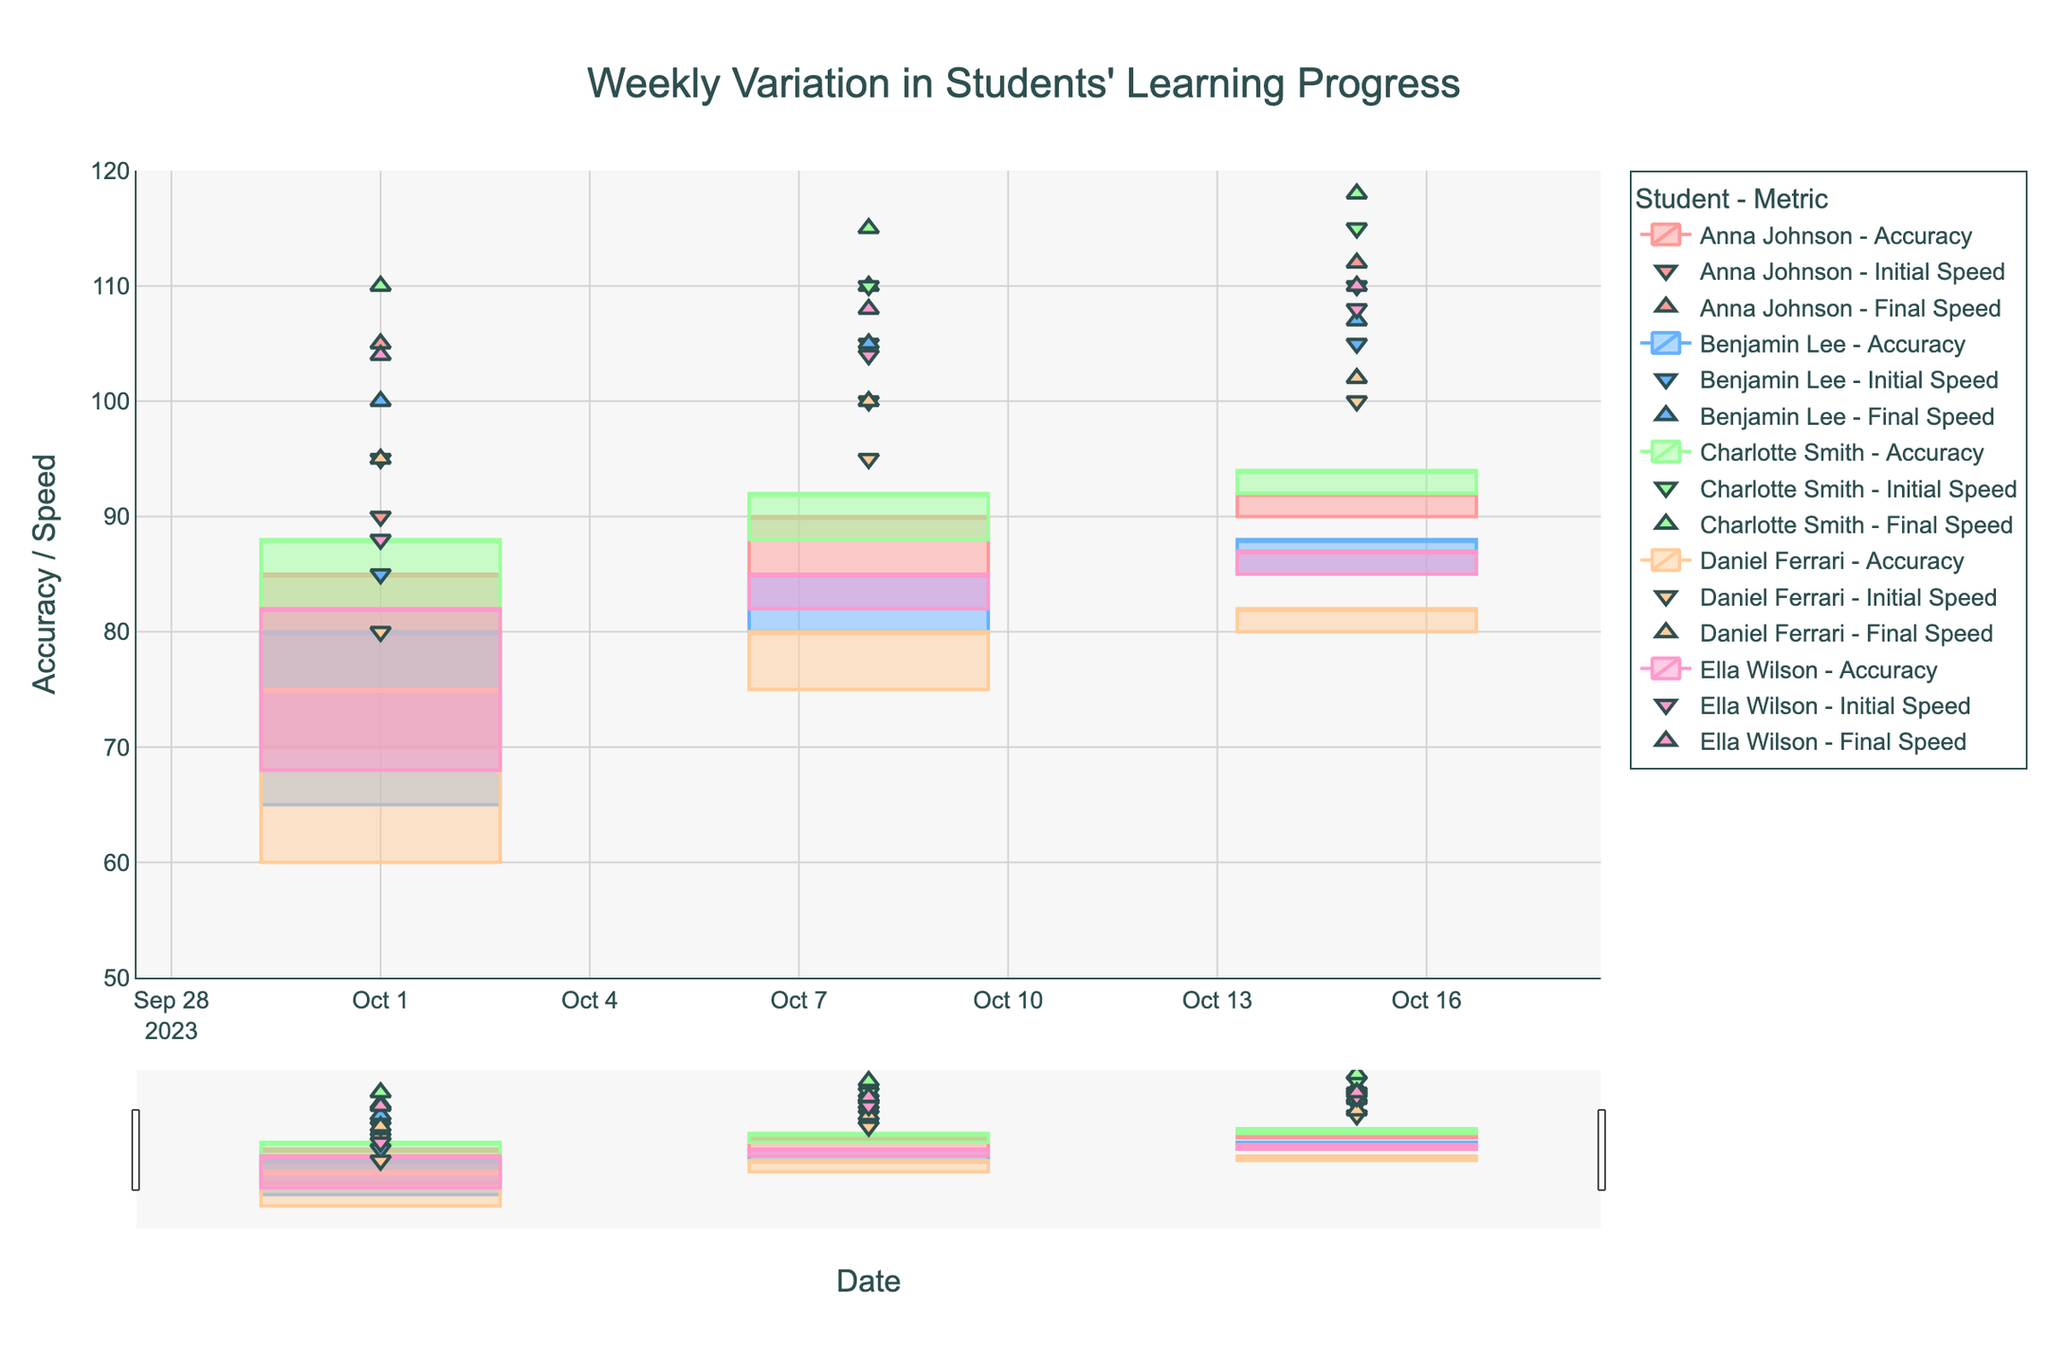What is the title of the figure? The title is typically located at the top of the figure. In this case, it is specified in the code under the `fig.update_layout` method. By looking at the figure, you can easily identify the title.
Answer: Weekly Variation in Students' Learning Progress What is the range of the y-axis? The y-axis range is usually determined by the minimum and maximum values on the y-axis. In this figure, it is set directly in the `fig.update_yaxes` method. By observing the figure, you would notice the range.
Answer: 50 to 120 Which student showed the highest increase in accuracy between 2023-10-01 and 2023-10-08? To answer this, observe the candlestick plots for each student between the mentioned dates. Subtract the initial accuracy on 2023-10-01 from the final accuracy on 2023-10-08 for each student. The student with the highest difference is the one who improved the most.
Answer: Charlotte Smith What is the overall trend in playing speed for Anna Johnson? Look at the scatter plot markers for Anna Johnson, specifically the triangle-down and triangle-up symbols, across all dates. Observe whether the values are increasing, decreasing, or remaining stable over time.
Answer: Increasing Which student had the smallest difference between initial and final accuracy on 2023-10-15? To determine this, compare the initial and final accuracy values on 2023-10-15 for all students. Subtract the final accuracy by the initial accuracy for each student and find the one with the smallest difference.
Answer: Anna Johnson How does the final accuracy of Benjamin Lee on 2023-10-08 compare with his final accuracy on 2023-10-15? Observe the final accuracy values for Benjamin Lee on the specified dates by checking the top of the candlestick for each respective date. Compare the two values directly.
Answer: 85 on 2023-10-08, 88 on 2023-10-15 Which student had the highest initial speed throughout the recorded periods? Look at the scatter plot markers representing the initial speed (triangle-down) for all students on all dates. Identify the highest value among these markers.
Answer: Charlotte Smith How do the accuracy levels between Anna Johnson and Benjamin Lee compare on 2023-10-15? Check the candlestick plots for both students on the specified date. Compare both the initial and final accuracy values for Anna Johnson and Benjamin Lee on 2023-10-15.
Answer: Anna Johnson: 90-92, Benjamin Lee: 85-88 What was the change in Ella Wilson's speed from 2023-10-01 to 2023-10-15? Identify Ella Wilson's initial and final speed values on both dates from the scatter plots. Subtract the initial speed on 2023-10-01 from the final speed on 2023-10-15.
Answer: 22 Which student had the most consistent improvement in accuracy over the weeks? To determine consistency in improvement, observe the candlestick plots for each student across all dates. The student whose candlesticks show steady and regular increases in both initial and final accuracy is the most consistent.
Answer: Anna Johnson 